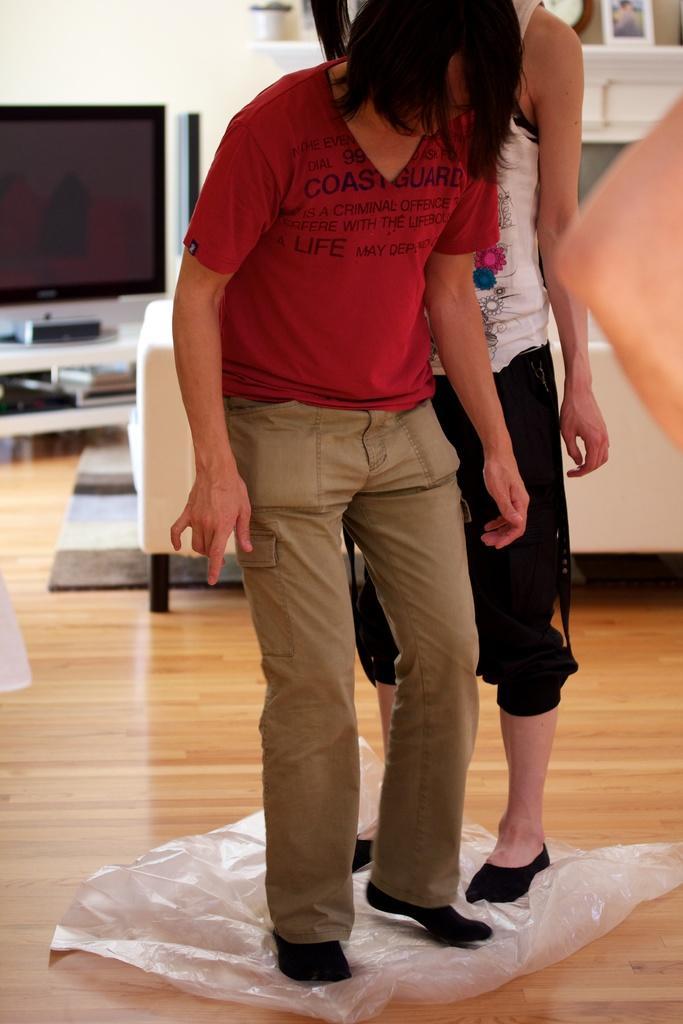Please provide a concise description of this image. In this image there are two people standing on the cover. Behind them there is a sofa. There is a TV. There is a stabilizer and a few other objects on the table. At the bottom of the image there is a floor. On the right side of the image we can see the hand of a person. In the background of the image there is a photo frame and a few other objects on the platform. There is a wall. 